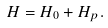Convert formula to latex. <formula><loc_0><loc_0><loc_500><loc_500>H = H _ { 0 } + H _ { p } .</formula> 